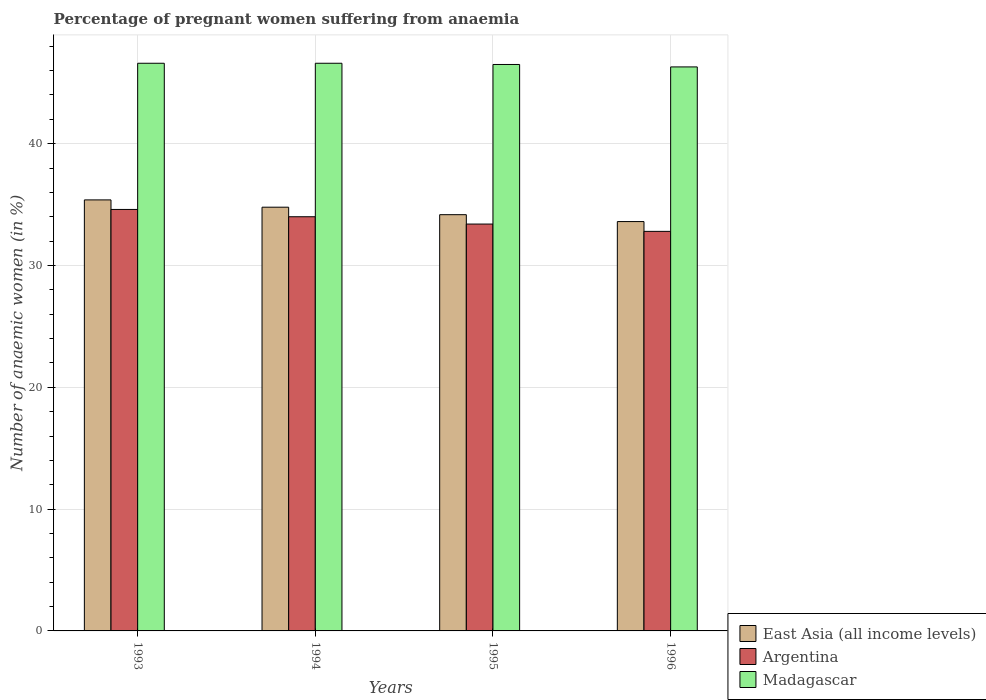How many different coloured bars are there?
Offer a very short reply. 3. How many groups of bars are there?
Offer a terse response. 4. Are the number of bars per tick equal to the number of legend labels?
Offer a terse response. Yes. Are the number of bars on each tick of the X-axis equal?
Give a very brief answer. Yes. How many bars are there on the 1st tick from the left?
Provide a short and direct response. 3. How many bars are there on the 4th tick from the right?
Offer a terse response. 3. In how many cases, is the number of bars for a given year not equal to the number of legend labels?
Keep it short and to the point. 0. What is the number of anaemic women in East Asia (all income levels) in 1994?
Make the answer very short. 34.78. Across all years, what is the maximum number of anaemic women in Madagascar?
Make the answer very short. 46.6. Across all years, what is the minimum number of anaemic women in Madagascar?
Make the answer very short. 46.3. In which year was the number of anaemic women in Argentina maximum?
Make the answer very short. 1993. In which year was the number of anaemic women in East Asia (all income levels) minimum?
Provide a succinct answer. 1996. What is the total number of anaemic women in East Asia (all income levels) in the graph?
Ensure brevity in your answer.  137.94. What is the difference between the number of anaemic women in Argentina in 1994 and that in 1995?
Your response must be concise. 0.6. What is the difference between the number of anaemic women in East Asia (all income levels) in 1996 and the number of anaemic women in Madagascar in 1994?
Make the answer very short. -13. What is the average number of anaemic women in Argentina per year?
Your answer should be very brief. 33.7. In the year 1995, what is the difference between the number of anaemic women in Madagascar and number of anaemic women in Argentina?
Your response must be concise. 13.1. In how many years, is the number of anaemic women in East Asia (all income levels) greater than 44 %?
Ensure brevity in your answer.  0. What is the ratio of the number of anaemic women in Argentina in 1994 to that in 1996?
Make the answer very short. 1.04. What is the difference between the highest and the second highest number of anaemic women in East Asia (all income levels)?
Offer a very short reply. 0.6. What is the difference between the highest and the lowest number of anaemic women in Madagascar?
Your answer should be compact. 0.3. What does the 2nd bar from the left in 1993 represents?
Keep it short and to the point. Argentina. What does the 3rd bar from the right in 1994 represents?
Offer a terse response. East Asia (all income levels). How many bars are there?
Make the answer very short. 12. Are all the bars in the graph horizontal?
Provide a short and direct response. No. How many years are there in the graph?
Your answer should be compact. 4. Does the graph contain any zero values?
Keep it short and to the point. No. Where does the legend appear in the graph?
Give a very brief answer. Bottom right. How many legend labels are there?
Keep it short and to the point. 3. How are the legend labels stacked?
Make the answer very short. Vertical. What is the title of the graph?
Your answer should be very brief. Percentage of pregnant women suffering from anaemia. What is the label or title of the X-axis?
Your answer should be very brief. Years. What is the label or title of the Y-axis?
Make the answer very short. Number of anaemic women (in %). What is the Number of anaemic women (in %) in East Asia (all income levels) in 1993?
Your response must be concise. 35.38. What is the Number of anaemic women (in %) in Argentina in 1993?
Offer a terse response. 34.6. What is the Number of anaemic women (in %) of Madagascar in 1993?
Provide a succinct answer. 46.6. What is the Number of anaemic women (in %) in East Asia (all income levels) in 1994?
Give a very brief answer. 34.78. What is the Number of anaemic women (in %) in Madagascar in 1994?
Offer a very short reply. 46.6. What is the Number of anaemic women (in %) in East Asia (all income levels) in 1995?
Your answer should be compact. 34.17. What is the Number of anaemic women (in %) of Argentina in 1995?
Keep it short and to the point. 33.4. What is the Number of anaemic women (in %) of Madagascar in 1995?
Ensure brevity in your answer.  46.5. What is the Number of anaemic women (in %) in East Asia (all income levels) in 1996?
Give a very brief answer. 33.6. What is the Number of anaemic women (in %) in Argentina in 1996?
Offer a very short reply. 32.8. What is the Number of anaemic women (in %) in Madagascar in 1996?
Offer a terse response. 46.3. Across all years, what is the maximum Number of anaemic women (in %) of East Asia (all income levels)?
Your answer should be very brief. 35.38. Across all years, what is the maximum Number of anaemic women (in %) in Argentina?
Your answer should be compact. 34.6. Across all years, what is the maximum Number of anaemic women (in %) of Madagascar?
Provide a succinct answer. 46.6. Across all years, what is the minimum Number of anaemic women (in %) of East Asia (all income levels)?
Your response must be concise. 33.6. Across all years, what is the minimum Number of anaemic women (in %) in Argentina?
Your response must be concise. 32.8. Across all years, what is the minimum Number of anaemic women (in %) in Madagascar?
Provide a succinct answer. 46.3. What is the total Number of anaemic women (in %) in East Asia (all income levels) in the graph?
Your response must be concise. 137.94. What is the total Number of anaemic women (in %) in Argentina in the graph?
Provide a succinct answer. 134.8. What is the total Number of anaemic women (in %) in Madagascar in the graph?
Keep it short and to the point. 186. What is the difference between the Number of anaemic women (in %) of East Asia (all income levels) in 1993 and that in 1994?
Keep it short and to the point. 0.6. What is the difference between the Number of anaemic women (in %) in East Asia (all income levels) in 1993 and that in 1995?
Provide a short and direct response. 1.21. What is the difference between the Number of anaemic women (in %) of Madagascar in 1993 and that in 1995?
Provide a succinct answer. 0.1. What is the difference between the Number of anaemic women (in %) in East Asia (all income levels) in 1993 and that in 1996?
Ensure brevity in your answer.  1.78. What is the difference between the Number of anaemic women (in %) in Argentina in 1993 and that in 1996?
Offer a terse response. 1.8. What is the difference between the Number of anaemic women (in %) in East Asia (all income levels) in 1994 and that in 1995?
Provide a succinct answer. 0.61. What is the difference between the Number of anaemic women (in %) of East Asia (all income levels) in 1994 and that in 1996?
Make the answer very short. 1.18. What is the difference between the Number of anaemic women (in %) of Argentina in 1994 and that in 1996?
Provide a succinct answer. 1.2. What is the difference between the Number of anaemic women (in %) of East Asia (all income levels) in 1995 and that in 1996?
Ensure brevity in your answer.  0.57. What is the difference between the Number of anaemic women (in %) in East Asia (all income levels) in 1993 and the Number of anaemic women (in %) in Argentina in 1994?
Provide a short and direct response. 1.38. What is the difference between the Number of anaemic women (in %) of East Asia (all income levels) in 1993 and the Number of anaemic women (in %) of Madagascar in 1994?
Your answer should be very brief. -11.22. What is the difference between the Number of anaemic women (in %) of Argentina in 1993 and the Number of anaemic women (in %) of Madagascar in 1994?
Offer a terse response. -12. What is the difference between the Number of anaemic women (in %) in East Asia (all income levels) in 1993 and the Number of anaemic women (in %) in Argentina in 1995?
Provide a short and direct response. 1.98. What is the difference between the Number of anaemic women (in %) in East Asia (all income levels) in 1993 and the Number of anaemic women (in %) in Madagascar in 1995?
Your response must be concise. -11.12. What is the difference between the Number of anaemic women (in %) of East Asia (all income levels) in 1993 and the Number of anaemic women (in %) of Argentina in 1996?
Your answer should be very brief. 2.58. What is the difference between the Number of anaemic women (in %) of East Asia (all income levels) in 1993 and the Number of anaemic women (in %) of Madagascar in 1996?
Your answer should be compact. -10.92. What is the difference between the Number of anaemic women (in %) in Argentina in 1993 and the Number of anaemic women (in %) in Madagascar in 1996?
Ensure brevity in your answer.  -11.7. What is the difference between the Number of anaemic women (in %) in East Asia (all income levels) in 1994 and the Number of anaemic women (in %) in Argentina in 1995?
Your response must be concise. 1.38. What is the difference between the Number of anaemic women (in %) of East Asia (all income levels) in 1994 and the Number of anaemic women (in %) of Madagascar in 1995?
Your response must be concise. -11.72. What is the difference between the Number of anaemic women (in %) in East Asia (all income levels) in 1994 and the Number of anaemic women (in %) in Argentina in 1996?
Your answer should be compact. 1.98. What is the difference between the Number of anaemic women (in %) in East Asia (all income levels) in 1994 and the Number of anaemic women (in %) in Madagascar in 1996?
Your answer should be compact. -11.52. What is the difference between the Number of anaemic women (in %) of East Asia (all income levels) in 1995 and the Number of anaemic women (in %) of Argentina in 1996?
Keep it short and to the point. 1.37. What is the difference between the Number of anaemic women (in %) in East Asia (all income levels) in 1995 and the Number of anaemic women (in %) in Madagascar in 1996?
Provide a succinct answer. -12.13. What is the average Number of anaemic women (in %) in East Asia (all income levels) per year?
Make the answer very short. 34.48. What is the average Number of anaemic women (in %) of Argentina per year?
Your answer should be compact. 33.7. What is the average Number of anaemic women (in %) of Madagascar per year?
Your response must be concise. 46.5. In the year 1993, what is the difference between the Number of anaemic women (in %) of East Asia (all income levels) and Number of anaemic women (in %) of Argentina?
Give a very brief answer. 0.78. In the year 1993, what is the difference between the Number of anaemic women (in %) of East Asia (all income levels) and Number of anaemic women (in %) of Madagascar?
Offer a very short reply. -11.22. In the year 1994, what is the difference between the Number of anaemic women (in %) of East Asia (all income levels) and Number of anaemic women (in %) of Argentina?
Provide a succinct answer. 0.78. In the year 1994, what is the difference between the Number of anaemic women (in %) of East Asia (all income levels) and Number of anaemic women (in %) of Madagascar?
Your response must be concise. -11.82. In the year 1994, what is the difference between the Number of anaemic women (in %) in Argentina and Number of anaemic women (in %) in Madagascar?
Make the answer very short. -12.6. In the year 1995, what is the difference between the Number of anaemic women (in %) in East Asia (all income levels) and Number of anaemic women (in %) in Argentina?
Keep it short and to the point. 0.77. In the year 1995, what is the difference between the Number of anaemic women (in %) of East Asia (all income levels) and Number of anaemic women (in %) of Madagascar?
Your response must be concise. -12.33. In the year 1995, what is the difference between the Number of anaemic women (in %) in Argentina and Number of anaemic women (in %) in Madagascar?
Offer a terse response. -13.1. In the year 1996, what is the difference between the Number of anaemic women (in %) in East Asia (all income levels) and Number of anaemic women (in %) in Argentina?
Your answer should be compact. 0.8. In the year 1996, what is the difference between the Number of anaemic women (in %) of East Asia (all income levels) and Number of anaemic women (in %) of Madagascar?
Offer a terse response. -12.7. In the year 1996, what is the difference between the Number of anaemic women (in %) in Argentina and Number of anaemic women (in %) in Madagascar?
Your answer should be very brief. -13.5. What is the ratio of the Number of anaemic women (in %) of East Asia (all income levels) in 1993 to that in 1994?
Provide a short and direct response. 1.02. What is the ratio of the Number of anaemic women (in %) of Argentina in 1993 to that in 1994?
Make the answer very short. 1.02. What is the ratio of the Number of anaemic women (in %) in East Asia (all income levels) in 1993 to that in 1995?
Offer a terse response. 1.04. What is the ratio of the Number of anaemic women (in %) in Argentina in 1993 to that in 1995?
Make the answer very short. 1.04. What is the ratio of the Number of anaemic women (in %) of Madagascar in 1993 to that in 1995?
Ensure brevity in your answer.  1. What is the ratio of the Number of anaemic women (in %) in East Asia (all income levels) in 1993 to that in 1996?
Your answer should be compact. 1.05. What is the ratio of the Number of anaemic women (in %) in Argentina in 1993 to that in 1996?
Offer a very short reply. 1.05. What is the ratio of the Number of anaemic women (in %) of East Asia (all income levels) in 1994 to that in 1995?
Offer a very short reply. 1.02. What is the ratio of the Number of anaemic women (in %) in East Asia (all income levels) in 1994 to that in 1996?
Your answer should be very brief. 1.04. What is the ratio of the Number of anaemic women (in %) of Argentina in 1994 to that in 1996?
Keep it short and to the point. 1.04. What is the ratio of the Number of anaemic women (in %) of Madagascar in 1994 to that in 1996?
Provide a short and direct response. 1.01. What is the ratio of the Number of anaemic women (in %) in East Asia (all income levels) in 1995 to that in 1996?
Provide a short and direct response. 1.02. What is the ratio of the Number of anaemic women (in %) in Argentina in 1995 to that in 1996?
Ensure brevity in your answer.  1.02. What is the ratio of the Number of anaemic women (in %) in Madagascar in 1995 to that in 1996?
Ensure brevity in your answer.  1. What is the difference between the highest and the second highest Number of anaemic women (in %) in East Asia (all income levels)?
Make the answer very short. 0.6. What is the difference between the highest and the second highest Number of anaemic women (in %) in Madagascar?
Ensure brevity in your answer.  0. What is the difference between the highest and the lowest Number of anaemic women (in %) of East Asia (all income levels)?
Your answer should be very brief. 1.78. What is the difference between the highest and the lowest Number of anaemic women (in %) in Argentina?
Your response must be concise. 1.8. What is the difference between the highest and the lowest Number of anaemic women (in %) of Madagascar?
Make the answer very short. 0.3. 